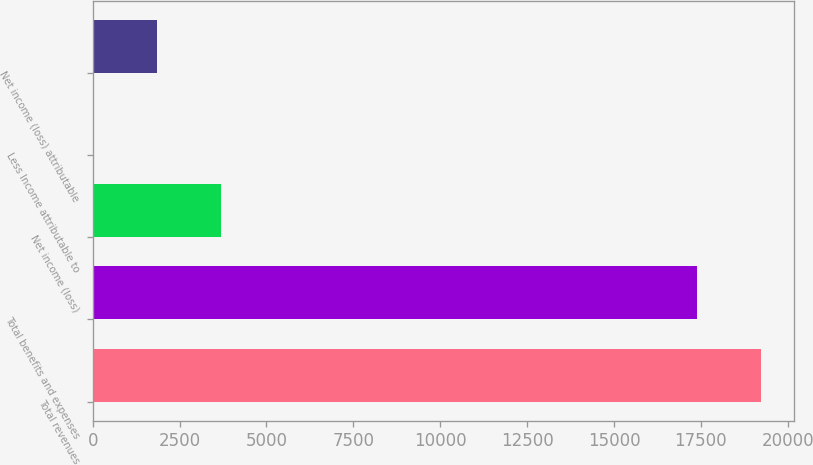<chart> <loc_0><loc_0><loc_500><loc_500><bar_chart><fcel>Total revenues<fcel>Total benefits and expenses<fcel>Net income (loss)<fcel>Less Income attributable to<fcel>Net income (loss) attributable<nl><fcel>19221.5<fcel>17379<fcel>3692<fcel>7<fcel>1849.5<nl></chart> 